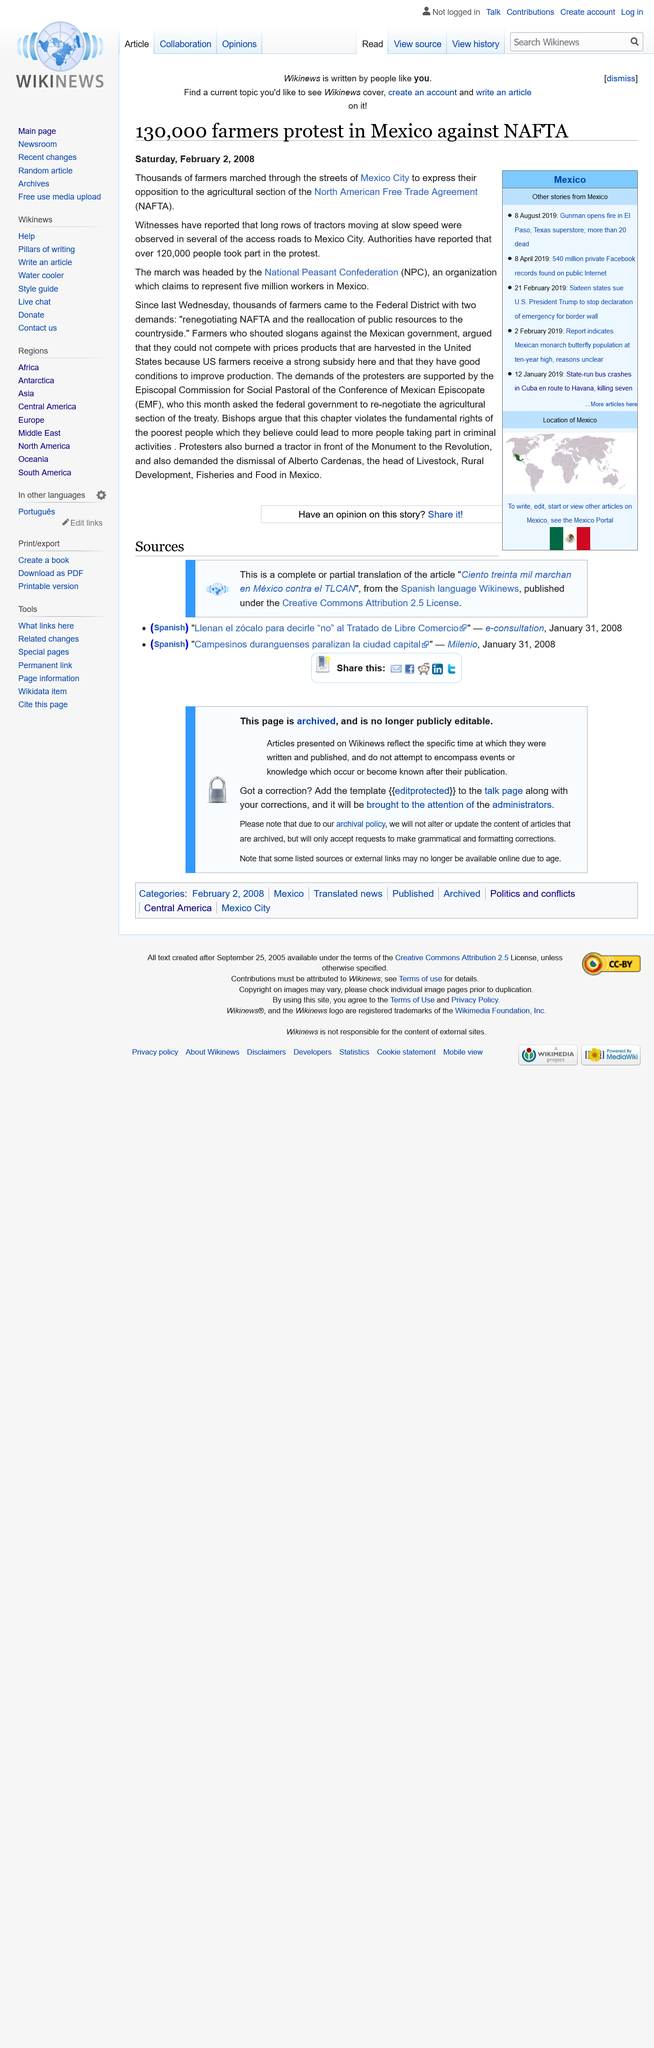Point out several critical features in this image. The National Peasant Confederation led the protest. It is estimated that over 120,000 people participated in the protest. Farmers protested against the agricultural provisions of the North American Free Trade Agreement in order to express their opposition. 